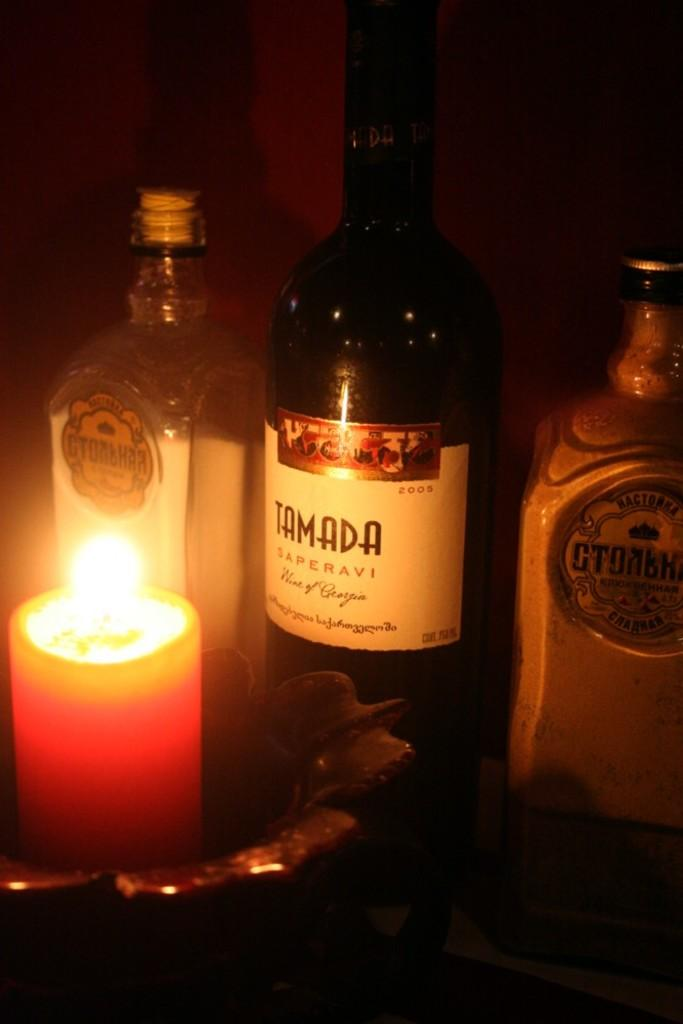Provide a one-sentence caption for the provided image. The table is lit with candle light and there is a bottle of Tamada wine displayed. 